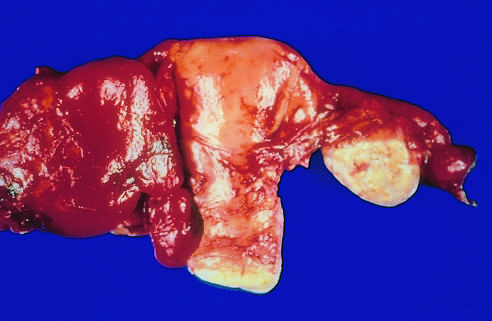what are totally obscured by a hemorrhagic inflammatory mass?
Answer the question using a single word or phrase. The tube and ovary to the left of the uterus 